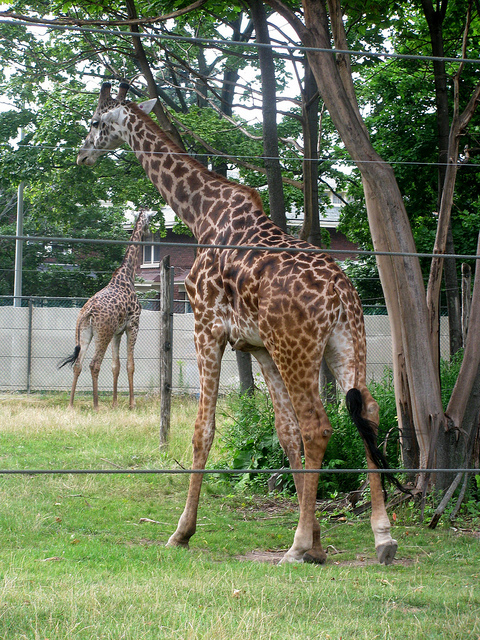<image>Where is the baby mother? It is unclear where the baby mother is. It may be across the pen or in the enclosure. Where is the baby mother? It is ambiguous where the baby's mother is. She can be in a separate pen, sleeping, across the pen, outside, or in the foreground. 